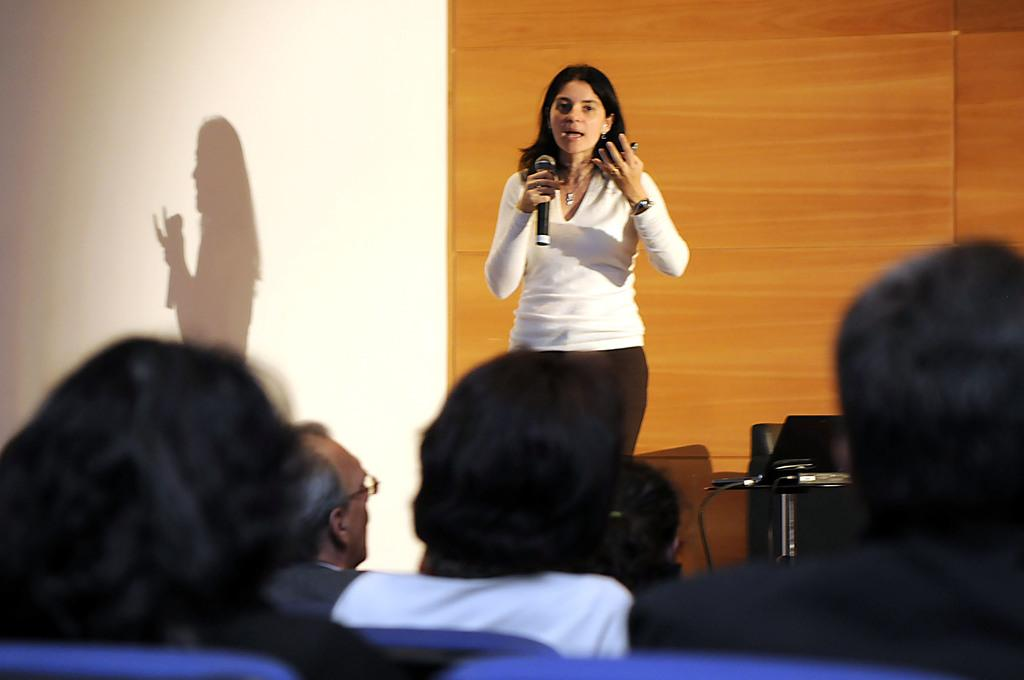Who is the main subject in the image? There is a lady in the image. What is the lady holding in the image? The lady is holding a microphone. What is the lady doing with the microphone? The lady is speaking to people. Can you describe the audience in the image? There are people sitting in front of the lady. Can you tell me how many squirrels are sitting in the front row of the audience? There are no squirrels present in the image; the audience consists of people. What type of knowledge is the lady sharing with the audience? The provided facts do not specify the topic or type of knowledge the lady is sharing with the audience. 